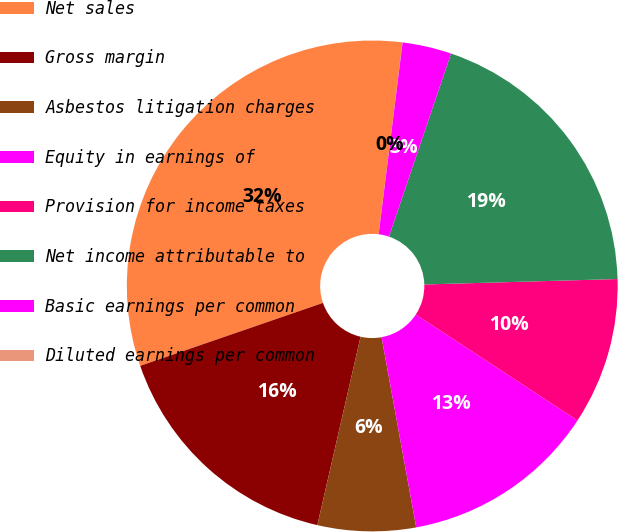Convert chart to OTSL. <chart><loc_0><loc_0><loc_500><loc_500><pie_chart><fcel>Net sales<fcel>Gross margin<fcel>Asbestos litigation charges<fcel>Equity in earnings of<fcel>Provision for income taxes<fcel>Net income attributable to<fcel>Basic earnings per common<fcel>Diluted earnings per common<nl><fcel>32.24%<fcel>16.13%<fcel>6.46%<fcel>12.9%<fcel>9.68%<fcel>19.35%<fcel>3.23%<fcel>0.01%<nl></chart> 